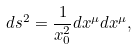<formula> <loc_0><loc_0><loc_500><loc_500>d s ^ { 2 } = \frac { 1 } { x _ { 0 } ^ { 2 } } d x ^ { \mu } d x ^ { \mu } ,</formula> 